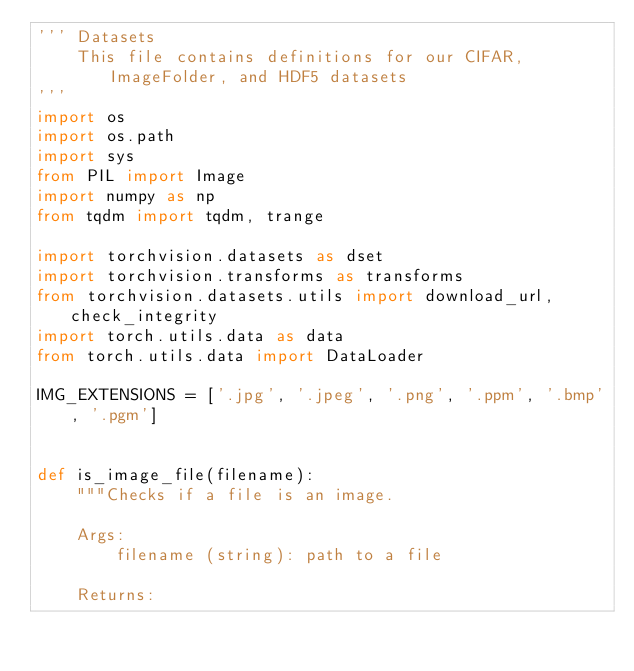<code> <loc_0><loc_0><loc_500><loc_500><_Python_>''' Datasets
    This file contains definitions for our CIFAR, ImageFolder, and HDF5 datasets
'''
import os
import os.path
import sys
from PIL import Image
import numpy as np
from tqdm import tqdm, trange

import torchvision.datasets as dset
import torchvision.transforms as transforms
from torchvision.datasets.utils import download_url, check_integrity
import torch.utils.data as data
from torch.utils.data import DataLoader
         
IMG_EXTENSIONS = ['.jpg', '.jpeg', '.png', '.ppm', '.bmp', '.pgm']


def is_image_file(filename):
    """Checks if a file is an image.

    Args:
        filename (string): path to a file

    Returns:</code> 